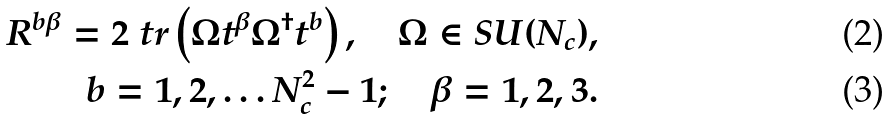<formula> <loc_0><loc_0><loc_500><loc_500>R ^ { b \beta } = 2 \ t r \left ( \Omega t ^ { \beta } \Omega ^ { \dagger } t ^ { b } \right ) , \quad \Omega \in S U ( N _ { c } ) , \\ b = 1 , 2 , \dots N _ { c } ^ { 2 } - 1 ; \quad \beta = 1 , 2 , 3 .</formula> 